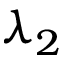<formula> <loc_0><loc_0><loc_500><loc_500>\lambda _ { 2 }</formula> 